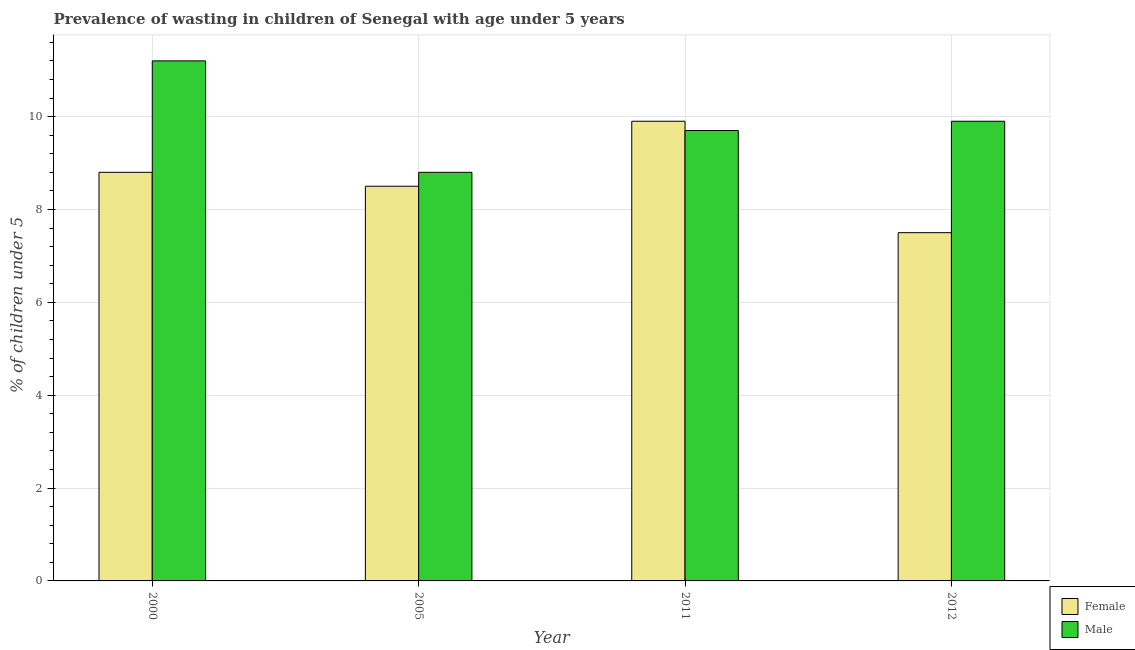How many different coloured bars are there?
Offer a very short reply. 2. Are the number of bars per tick equal to the number of legend labels?
Give a very brief answer. Yes. How many bars are there on the 4th tick from the left?
Give a very brief answer. 2. How many bars are there on the 2nd tick from the right?
Make the answer very short. 2. What is the percentage of undernourished female children in 2011?
Your answer should be very brief. 9.9. Across all years, what is the maximum percentage of undernourished male children?
Keep it short and to the point. 11.2. Across all years, what is the minimum percentage of undernourished female children?
Give a very brief answer. 7.5. In which year was the percentage of undernourished female children maximum?
Ensure brevity in your answer.  2011. In which year was the percentage of undernourished female children minimum?
Offer a very short reply. 2012. What is the total percentage of undernourished male children in the graph?
Your answer should be very brief. 39.6. What is the difference between the percentage of undernourished female children in 2005 and that in 2012?
Keep it short and to the point. 1. What is the difference between the percentage of undernourished male children in 2012 and the percentage of undernourished female children in 2000?
Give a very brief answer. -1.3. What is the average percentage of undernourished female children per year?
Your response must be concise. 8.67. In the year 2005, what is the difference between the percentage of undernourished male children and percentage of undernourished female children?
Provide a succinct answer. 0. What is the ratio of the percentage of undernourished female children in 2005 to that in 2011?
Keep it short and to the point. 0.86. What is the difference between the highest and the second highest percentage of undernourished female children?
Your answer should be compact. 1.1. What is the difference between the highest and the lowest percentage of undernourished female children?
Provide a short and direct response. 2.4. In how many years, is the percentage of undernourished male children greater than the average percentage of undernourished male children taken over all years?
Offer a very short reply. 1. Is the sum of the percentage of undernourished female children in 2000 and 2005 greater than the maximum percentage of undernourished male children across all years?
Your response must be concise. Yes. What does the 2nd bar from the left in 2000 represents?
Your answer should be very brief. Male. Does the graph contain grids?
Ensure brevity in your answer.  Yes. How many legend labels are there?
Offer a terse response. 2. What is the title of the graph?
Provide a succinct answer. Prevalence of wasting in children of Senegal with age under 5 years. Does "Crop" appear as one of the legend labels in the graph?
Offer a terse response. No. What is the label or title of the X-axis?
Keep it short and to the point. Year. What is the label or title of the Y-axis?
Provide a short and direct response.  % of children under 5. What is the  % of children under 5 of Female in 2000?
Provide a succinct answer. 8.8. What is the  % of children under 5 in Male in 2000?
Offer a terse response. 11.2. What is the  % of children under 5 in Male in 2005?
Your answer should be very brief. 8.8. What is the  % of children under 5 of Female in 2011?
Give a very brief answer. 9.9. What is the  % of children under 5 of Male in 2011?
Provide a short and direct response. 9.7. What is the  % of children under 5 of Female in 2012?
Offer a terse response. 7.5. What is the  % of children under 5 in Male in 2012?
Give a very brief answer. 9.9. Across all years, what is the maximum  % of children under 5 in Female?
Offer a very short reply. 9.9. Across all years, what is the maximum  % of children under 5 of Male?
Keep it short and to the point. 11.2. Across all years, what is the minimum  % of children under 5 in Male?
Offer a very short reply. 8.8. What is the total  % of children under 5 of Female in the graph?
Your answer should be compact. 34.7. What is the total  % of children under 5 of Male in the graph?
Your response must be concise. 39.6. What is the difference between the  % of children under 5 in Male in 2000 and that in 2005?
Your response must be concise. 2.4. What is the difference between the  % of children under 5 in Female in 2005 and that in 2011?
Keep it short and to the point. -1.4. What is the difference between the  % of children under 5 in Female in 2005 and that in 2012?
Your response must be concise. 1. What is the difference between the  % of children under 5 in Male in 2011 and that in 2012?
Your answer should be very brief. -0.2. What is the difference between the  % of children under 5 of Female in 2000 and the  % of children under 5 of Male in 2012?
Keep it short and to the point. -1.1. What is the difference between the  % of children under 5 of Female in 2011 and the  % of children under 5 of Male in 2012?
Make the answer very short. 0. What is the average  % of children under 5 in Female per year?
Make the answer very short. 8.68. What is the average  % of children under 5 of Male per year?
Offer a terse response. 9.9. In the year 2000, what is the difference between the  % of children under 5 in Female and  % of children under 5 in Male?
Provide a succinct answer. -2.4. In the year 2012, what is the difference between the  % of children under 5 in Female and  % of children under 5 in Male?
Your response must be concise. -2.4. What is the ratio of the  % of children under 5 in Female in 2000 to that in 2005?
Offer a very short reply. 1.04. What is the ratio of the  % of children under 5 in Male in 2000 to that in 2005?
Keep it short and to the point. 1.27. What is the ratio of the  % of children under 5 of Female in 2000 to that in 2011?
Your response must be concise. 0.89. What is the ratio of the  % of children under 5 in Male in 2000 to that in 2011?
Offer a terse response. 1.15. What is the ratio of the  % of children under 5 in Female in 2000 to that in 2012?
Offer a very short reply. 1.17. What is the ratio of the  % of children under 5 in Male in 2000 to that in 2012?
Make the answer very short. 1.13. What is the ratio of the  % of children under 5 of Female in 2005 to that in 2011?
Keep it short and to the point. 0.86. What is the ratio of the  % of children under 5 in Male in 2005 to that in 2011?
Keep it short and to the point. 0.91. What is the ratio of the  % of children under 5 in Female in 2005 to that in 2012?
Make the answer very short. 1.13. What is the ratio of the  % of children under 5 in Male in 2005 to that in 2012?
Make the answer very short. 0.89. What is the ratio of the  % of children under 5 in Female in 2011 to that in 2012?
Your answer should be very brief. 1.32. What is the ratio of the  % of children under 5 of Male in 2011 to that in 2012?
Offer a very short reply. 0.98. What is the difference between the highest and the second highest  % of children under 5 of Female?
Ensure brevity in your answer.  1.1. What is the difference between the highest and the second highest  % of children under 5 of Male?
Your answer should be compact. 1.3. What is the difference between the highest and the lowest  % of children under 5 in Male?
Ensure brevity in your answer.  2.4. 